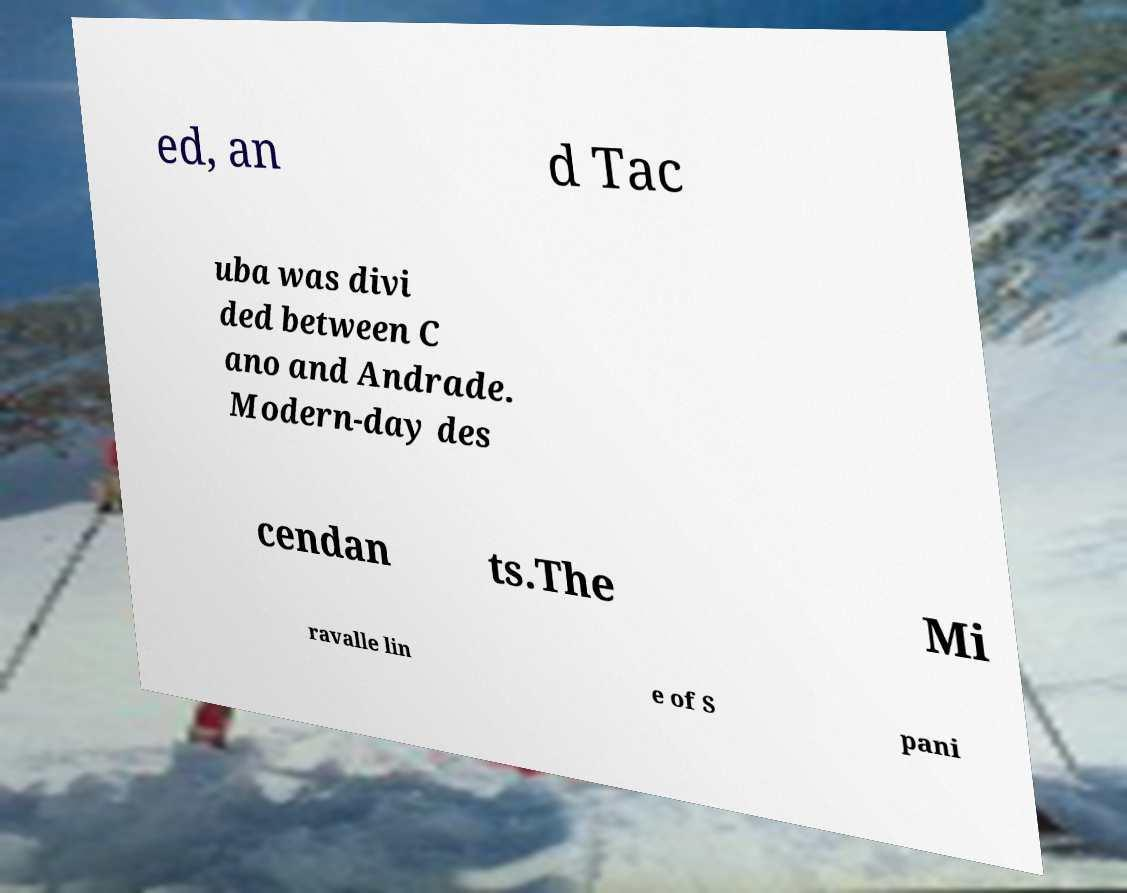Please read and relay the text visible in this image. What does it say? ed, an d Tac uba was divi ded between C ano and Andrade. Modern-day des cendan ts.The Mi ravalle lin e of S pani 